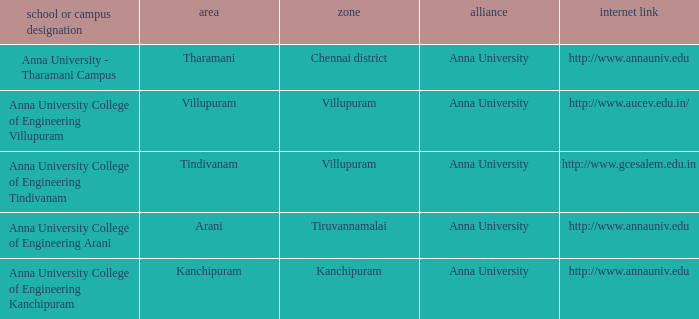What Weblink has a College or Campus Name of anna university college of engineering tindivanam? Http://www.gcesalem.edu.in. 